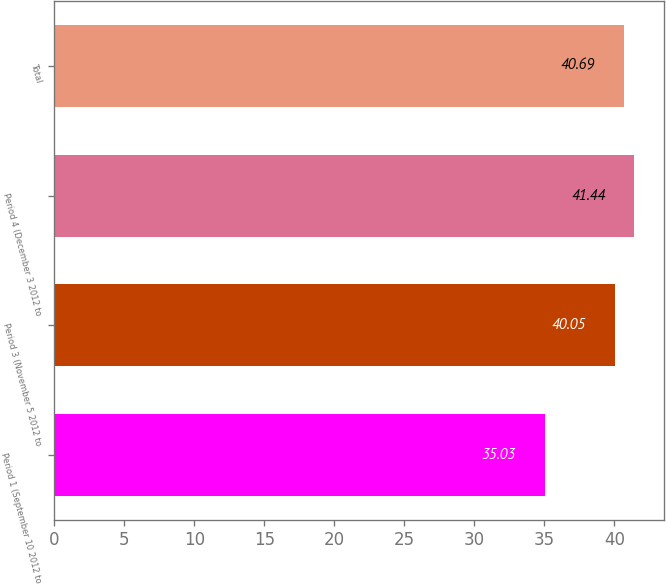Convert chart to OTSL. <chart><loc_0><loc_0><loc_500><loc_500><bar_chart><fcel>Period 1 (September 10 2012 to<fcel>Period 3 (November 5 2012 to<fcel>Period 4 (December 3 2012 to<fcel>Total<nl><fcel>35.03<fcel>40.05<fcel>41.44<fcel>40.69<nl></chart> 